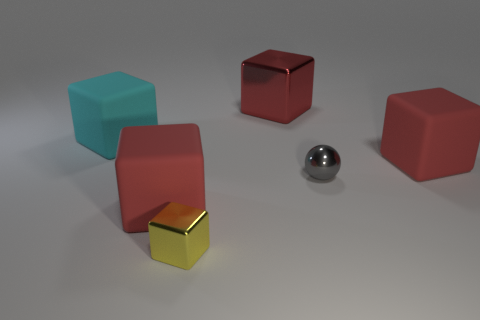What material do the objects in the image appear to be made of? The objects in the image appear to have a matte finish, suggesting they could be made of a plastic or painted wood. Their smooth surfaces and solid colors give them a simplistic, almost toy-like quality. 